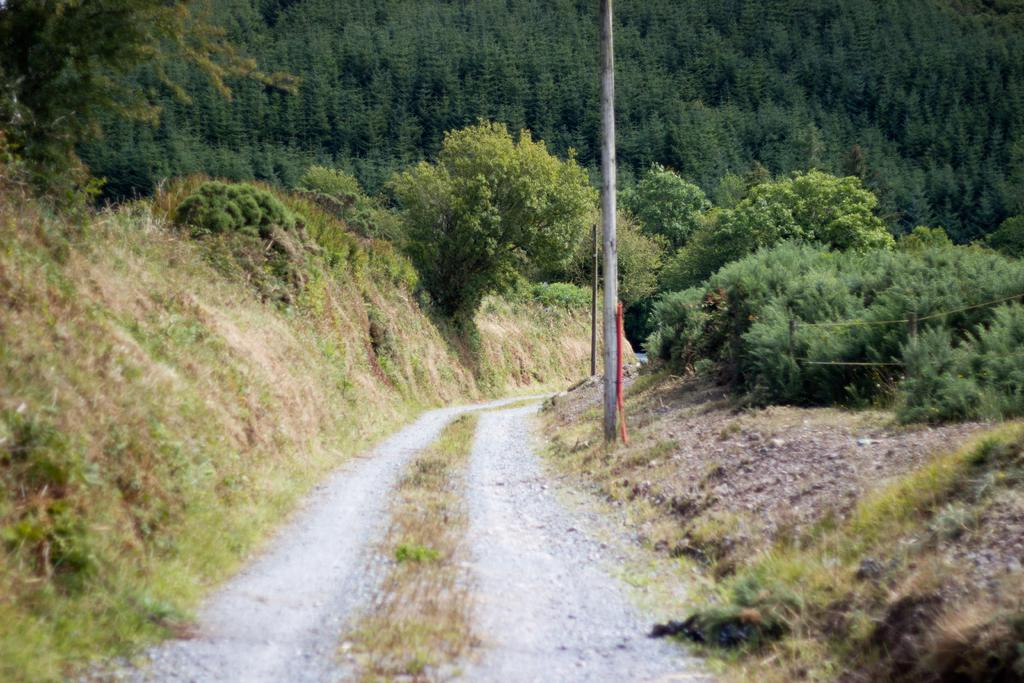What type of vegetation is present in the image? There is grass, plants, and trees in the image. Can you describe any other objects in the image? There is a pole in the image. What type of sofa can be seen in the image? There is no sofa present in the image. Is there a carpenter working on the pole in the image? There is no carpenter or any indication of work being done on the pole in the image. 